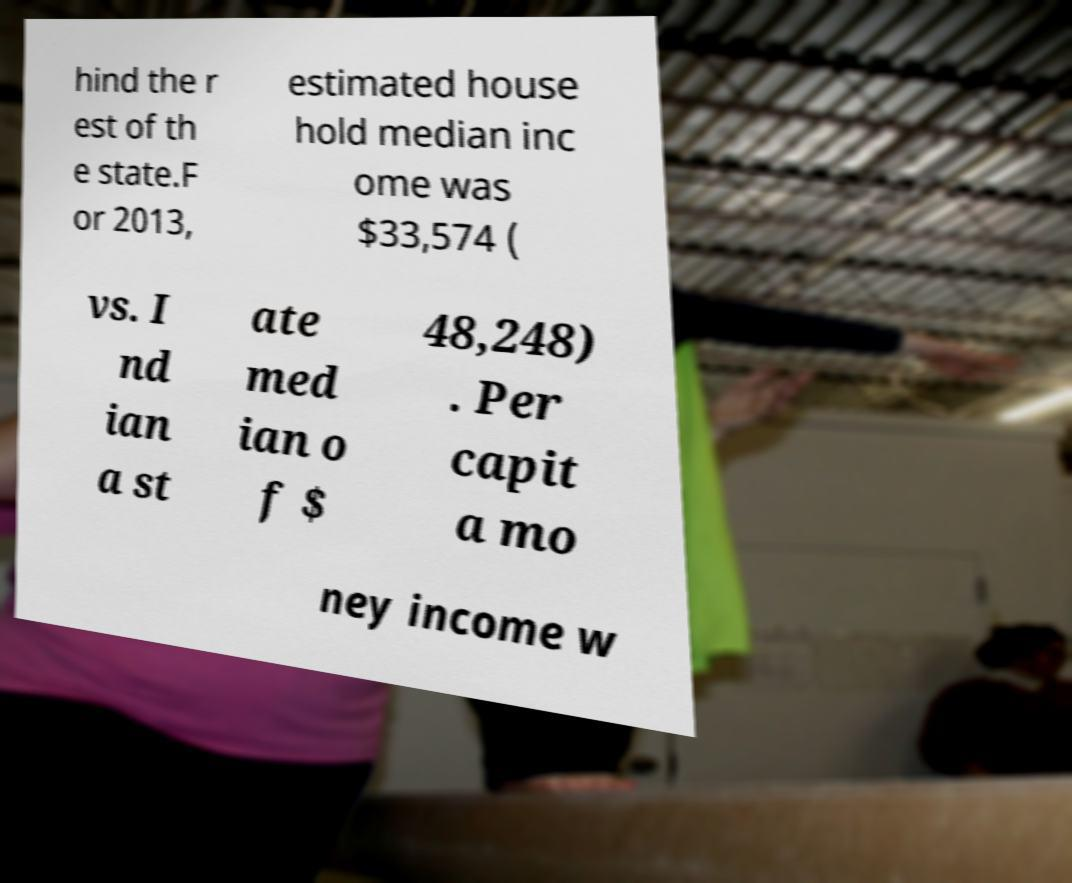Please identify and transcribe the text found in this image. hind the r est of th e state.F or 2013, estimated house hold median inc ome was $33,574 ( vs. I nd ian a st ate med ian o f $ 48,248) . Per capit a mo ney income w 